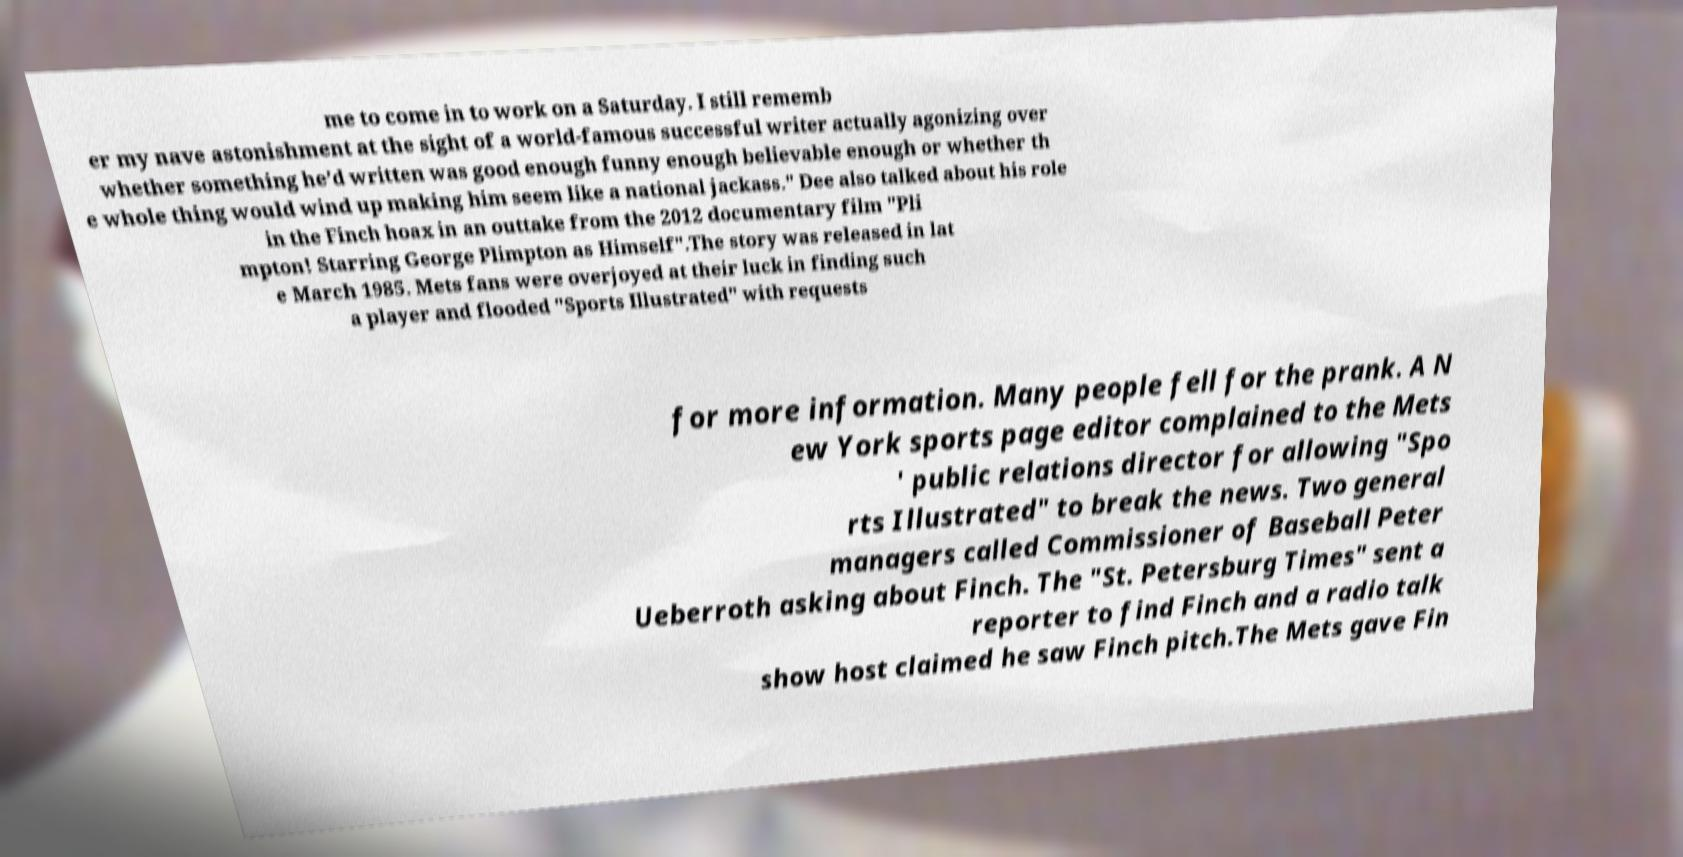There's text embedded in this image that I need extracted. Can you transcribe it verbatim? me to come in to work on a Saturday. I still rememb er my nave astonishment at the sight of a world-famous successful writer actually agonizing over whether something he’d written was good enough funny enough believable enough or whether th e whole thing would wind up making him seem like a national jackass." Dee also talked about his role in the Finch hoax in an outtake from the 2012 documentary film "Pli mpton! Starring George Plimpton as Himself".The story was released in lat e March 1985. Mets fans were overjoyed at their luck in finding such a player and flooded "Sports Illustrated" with requests for more information. Many people fell for the prank. A N ew York sports page editor complained to the Mets ' public relations director for allowing "Spo rts Illustrated" to break the news. Two general managers called Commissioner of Baseball Peter Ueberroth asking about Finch. The "St. Petersburg Times" sent a reporter to find Finch and a radio talk show host claimed he saw Finch pitch.The Mets gave Fin 